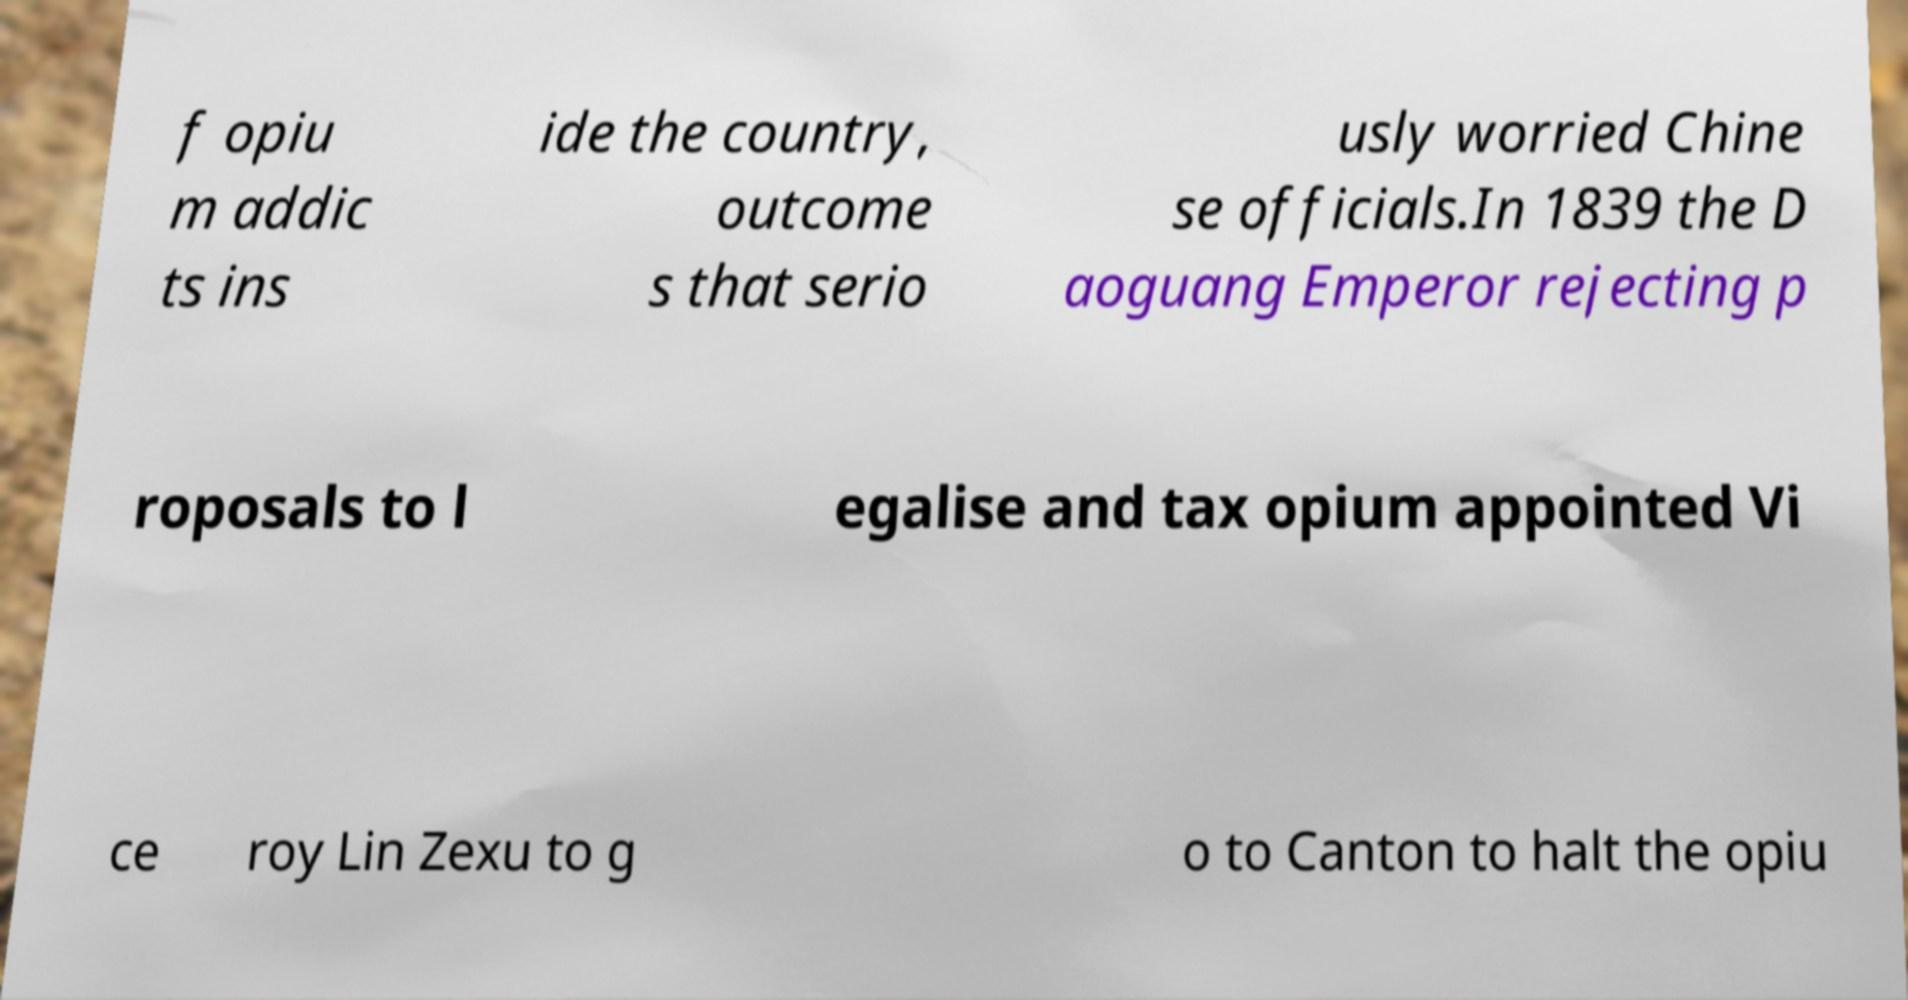I need the written content from this picture converted into text. Can you do that? f opiu m addic ts ins ide the country, outcome s that serio usly worried Chine se officials.In 1839 the D aoguang Emperor rejecting p roposals to l egalise and tax opium appointed Vi ce roy Lin Zexu to g o to Canton to halt the opiu 